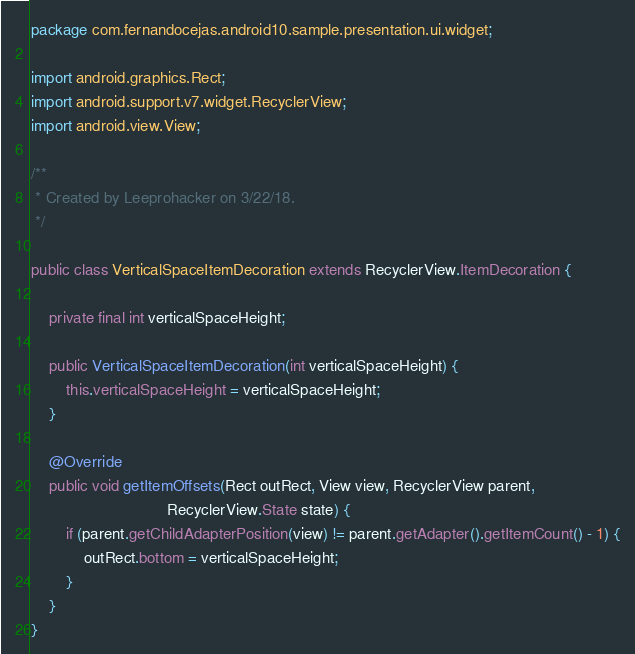Convert code to text. <code><loc_0><loc_0><loc_500><loc_500><_Java_>package com.fernandocejas.android10.sample.presentation.ui.widget;

import android.graphics.Rect;
import android.support.v7.widget.RecyclerView;
import android.view.View;

/**
 * Created by Leeprohacker on 3/22/18.
 */

public class VerticalSpaceItemDecoration extends RecyclerView.ItemDecoration {

    private final int verticalSpaceHeight;

    public VerticalSpaceItemDecoration(int verticalSpaceHeight) {
        this.verticalSpaceHeight = verticalSpaceHeight;
    }

    @Override
    public void getItemOffsets(Rect outRect, View view, RecyclerView parent,
                               RecyclerView.State state) {
        if (parent.getChildAdapterPosition(view) != parent.getAdapter().getItemCount() - 1) {
            outRect.bottom = verticalSpaceHeight;
        }
    }
}</code> 